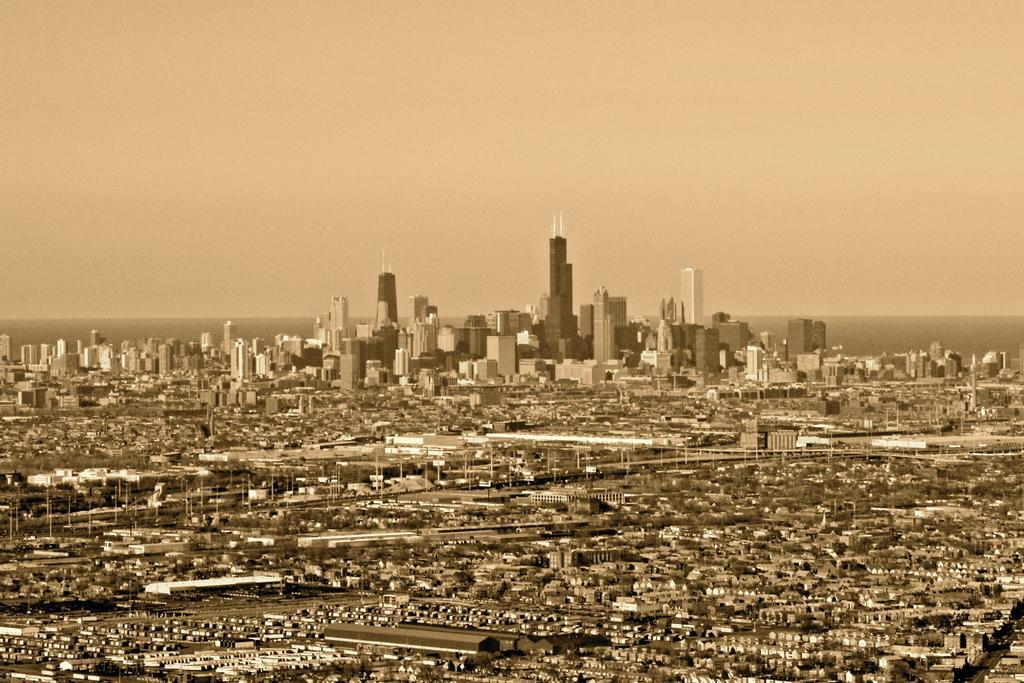Please provide a concise description of this image. In this image there are few buildings, trees, houses, poles and the sky. 